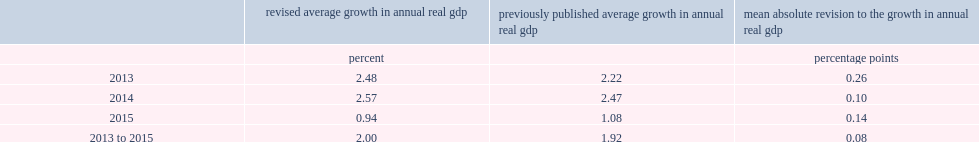What was the mean absolute percentage point revision to the annual growth rate in real gdp for the 2013 to 2015 revision period? 0.08. 